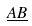Convert formula to latex. <formula><loc_0><loc_0><loc_500><loc_500>\underline { A B }</formula> 